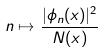Convert formula to latex. <formula><loc_0><loc_0><loc_500><loc_500>n \mapsto \frac { | \phi _ { n } ( x ) | ^ { 2 } } { N ( x ) }</formula> 